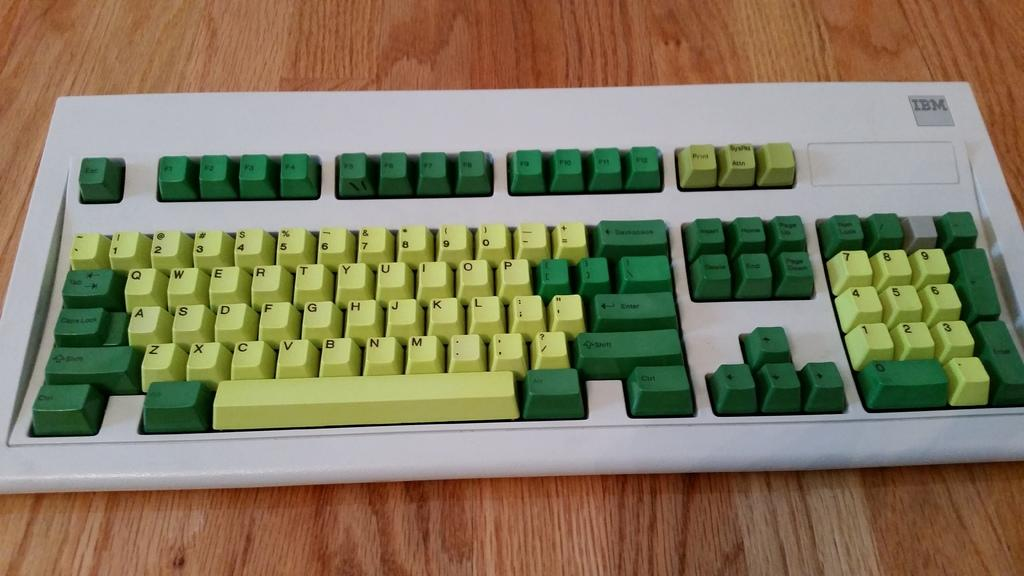<image>
Offer a succinct explanation of the picture presented. A green IBM brand keyboard is sitting on a wooden table. 